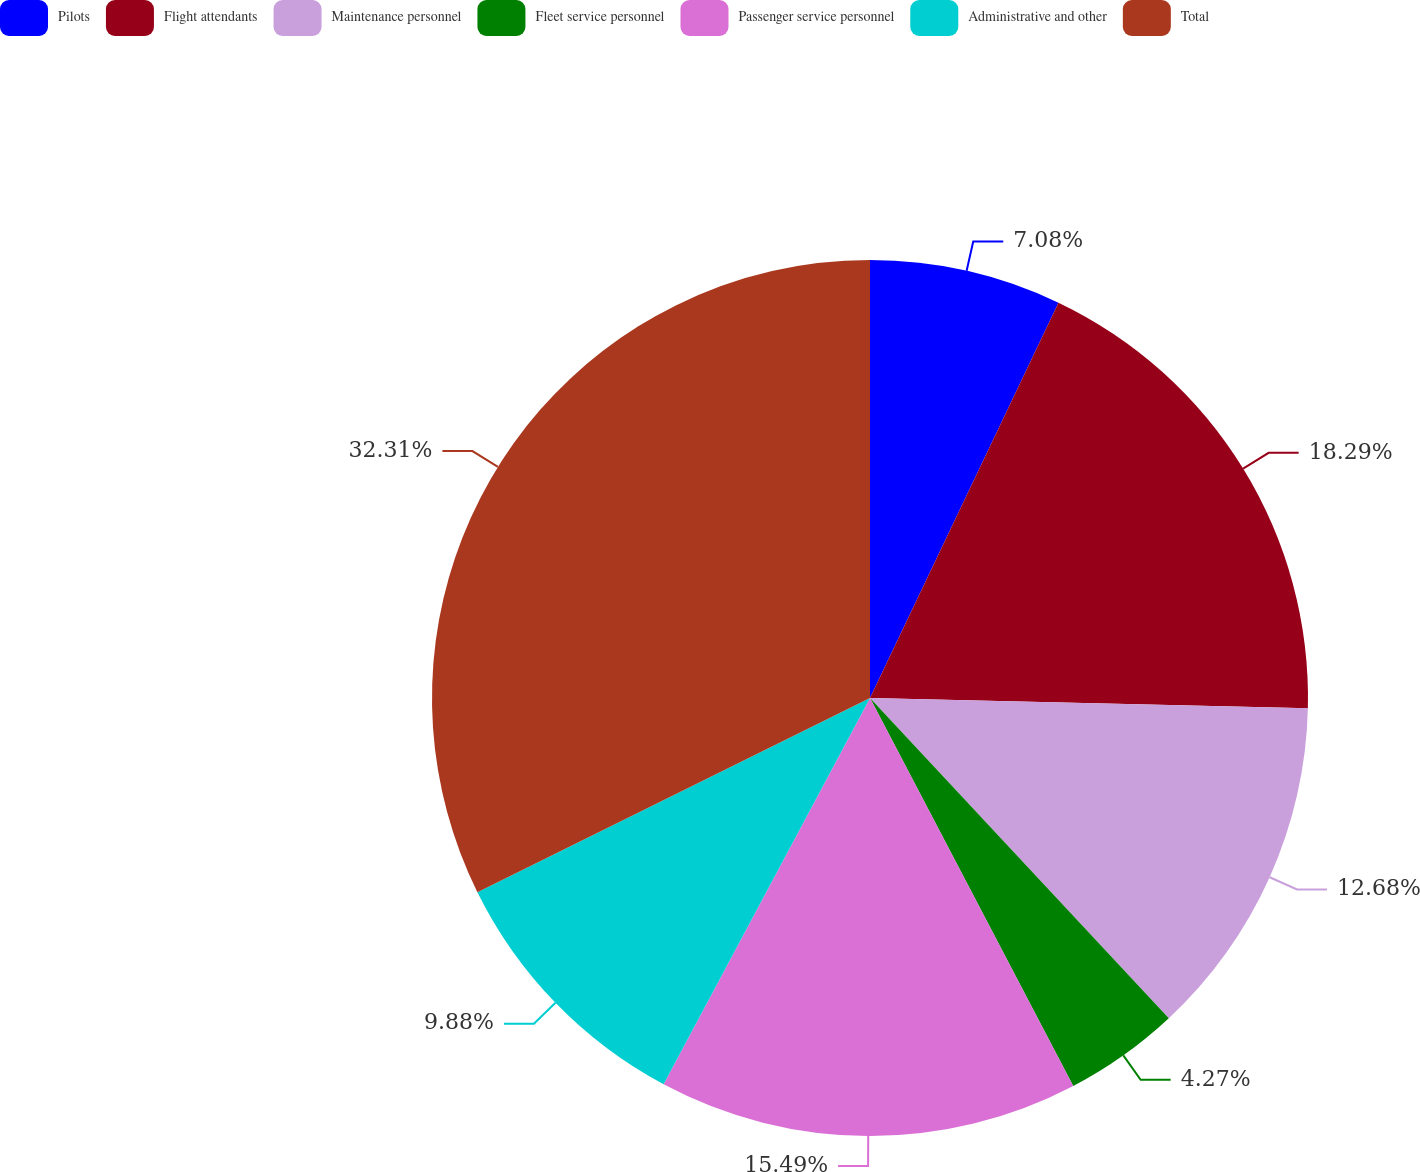Convert chart to OTSL. <chart><loc_0><loc_0><loc_500><loc_500><pie_chart><fcel>Pilots<fcel>Flight attendants<fcel>Maintenance personnel<fcel>Fleet service personnel<fcel>Passenger service personnel<fcel>Administrative and other<fcel>Total<nl><fcel>7.08%<fcel>18.29%<fcel>12.68%<fcel>4.27%<fcel>15.49%<fcel>9.88%<fcel>32.31%<nl></chart> 